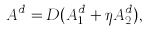Convert formula to latex. <formula><loc_0><loc_0><loc_500><loc_500>A ^ { d } = D ( A _ { 1 } ^ { d } + \eta A _ { 2 } ^ { d } ) ,</formula> 